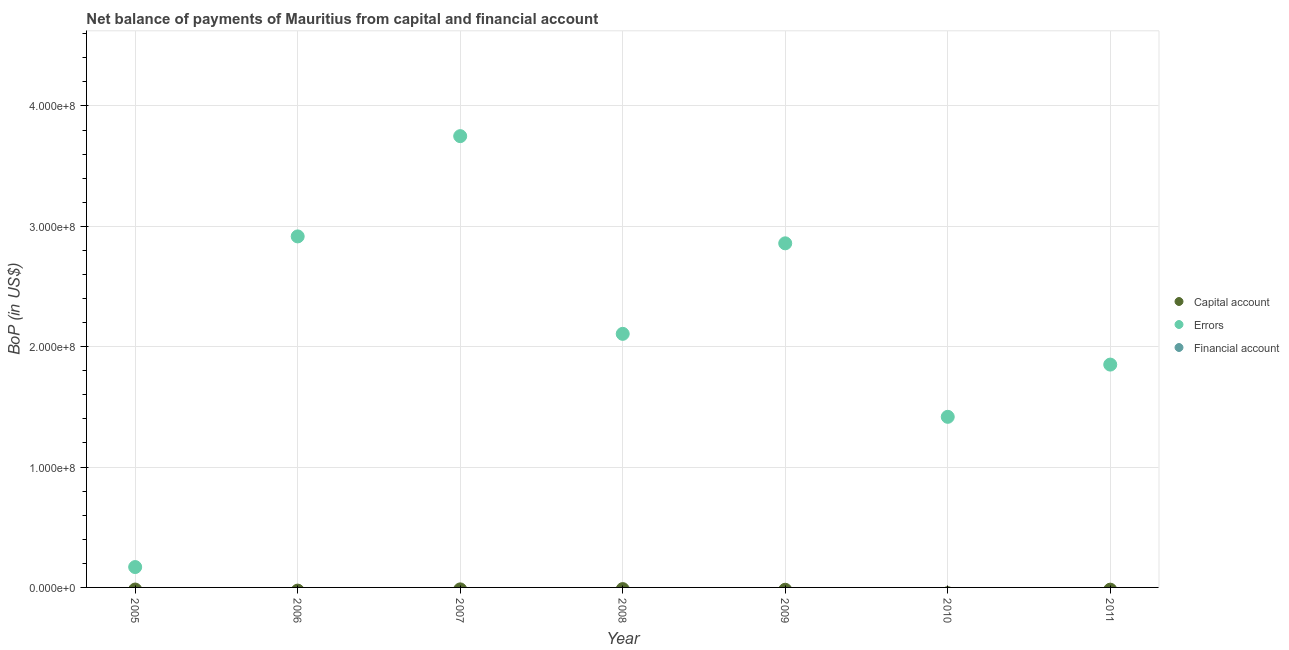What is the amount of errors in 2007?
Keep it short and to the point. 3.75e+08. Across all years, what is the maximum amount of errors?
Keep it short and to the point. 3.75e+08. In which year was the amount of errors maximum?
Your answer should be compact. 2007. What is the total amount of errors in the graph?
Offer a terse response. 1.51e+09. What is the difference between the amount of errors in 2007 and that in 2008?
Keep it short and to the point. 1.64e+08. What is the difference between the amount of errors in 2008 and the amount of net capital account in 2005?
Ensure brevity in your answer.  2.11e+08. What is the ratio of the amount of errors in 2005 to that in 2008?
Offer a terse response. 0.08. What is the difference between the highest and the second highest amount of errors?
Your response must be concise. 8.33e+07. What is the difference between the highest and the lowest amount of errors?
Offer a terse response. 3.58e+08. Is it the case that in every year, the sum of the amount of net capital account and amount of errors is greater than the amount of financial account?
Provide a short and direct response. Yes. Does the amount of errors monotonically increase over the years?
Your answer should be very brief. No. What is the difference between two consecutive major ticks on the Y-axis?
Keep it short and to the point. 1.00e+08. Are the values on the major ticks of Y-axis written in scientific E-notation?
Make the answer very short. Yes. Does the graph contain grids?
Provide a succinct answer. Yes. What is the title of the graph?
Your answer should be compact. Net balance of payments of Mauritius from capital and financial account. Does "Ages 60+" appear as one of the legend labels in the graph?
Your answer should be very brief. No. What is the label or title of the X-axis?
Your answer should be very brief. Year. What is the label or title of the Y-axis?
Provide a succinct answer. BoP (in US$). What is the BoP (in US$) in Errors in 2005?
Give a very brief answer. 1.69e+07. What is the BoP (in US$) in Capital account in 2006?
Your answer should be compact. 0. What is the BoP (in US$) in Errors in 2006?
Your answer should be compact. 2.92e+08. What is the BoP (in US$) of Financial account in 2006?
Give a very brief answer. 0. What is the BoP (in US$) in Errors in 2007?
Provide a short and direct response. 3.75e+08. What is the BoP (in US$) of Financial account in 2007?
Offer a very short reply. 0. What is the BoP (in US$) of Errors in 2008?
Provide a succinct answer. 2.11e+08. What is the BoP (in US$) of Capital account in 2009?
Ensure brevity in your answer.  0. What is the BoP (in US$) of Errors in 2009?
Give a very brief answer. 2.86e+08. What is the BoP (in US$) in Financial account in 2009?
Provide a succinct answer. 0. What is the BoP (in US$) in Errors in 2010?
Make the answer very short. 1.42e+08. What is the BoP (in US$) in Financial account in 2010?
Keep it short and to the point. 0. What is the BoP (in US$) of Capital account in 2011?
Keep it short and to the point. 0. What is the BoP (in US$) in Errors in 2011?
Make the answer very short. 1.85e+08. What is the BoP (in US$) in Financial account in 2011?
Give a very brief answer. 0. Across all years, what is the maximum BoP (in US$) in Errors?
Offer a terse response. 3.75e+08. Across all years, what is the minimum BoP (in US$) in Errors?
Provide a short and direct response. 1.69e+07. What is the total BoP (in US$) in Capital account in the graph?
Your answer should be very brief. 0. What is the total BoP (in US$) of Errors in the graph?
Give a very brief answer. 1.51e+09. What is the total BoP (in US$) in Financial account in the graph?
Provide a succinct answer. 0. What is the difference between the BoP (in US$) of Errors in 2005 and that in 2006?
Make the answer very short. -2.75e+08. What is the difference between the BoP (in US$) in Errors in 2005 and that in 2007?
Offer a terse response. -3.58e+08. What is the difference between the BoP (in US$) of Errors in 2005 and that in 2008?
Ensure brevity in your answer.  -1.94e+08. What is the difference between the BoP (in US$) in Errors in 2005 and that in 2009?
Your response must be concise. -2.69e+08. What is the difference between the BoP (in US$) of Errors in 2005 and that in 2010?
Provide a short and direct response. -1.25e+08. What is the difference between the BoP (in US$) of Errors in 2005 and that in 2011?
Keep it short and to the point. -1.68e+08. What is the difference between the BoP (in US$) in Errors in 2006 and that in 2007?
Your response must be concise. -8.33e+07. What is the difference between the BoP (in US$) of Errors in 2006 and that in 2008?
Give a very brief answer. 8.10e+07. What is the difference between the BoP (in US$) of Errors in 2006 and that in 2009?
Offer a very short reply. 5.75e+06. What is the difference between the BoP (in US$) of Errors in 2006 and that in 2010?
Your answer should be compact. 1.50e+08. What is the difference between the BoP (in US$) of Errors in 2006 and that in 2011?
Keep it short and to the point. 1.07e+08. What is the difference between the BoP (in US$) of Errors in 2007 and that in 2008?
Your response must be concise. 1.64e+08. What is the difference between the BoP (in US$) in Errors in 2007 and that in 2009?
Offer a terse response. 8.90e+07. What is the difference between the BoP (in US$) of Errors in 2007 and that in 2010?
Offer a very short reply. 2.33e+08. What is the difference between the BoP (in US$) of Errors in 2007 and that in 2011?
Provide a short and direct response. 1.90e+08. What is the difference between the BoP (in US$) of Errors in 2008 and that in 2009?
Ensure brevity in your answer.  -7.52e+07. What is the difference between the BoP (in US$) of Errors in 2008 and that in 2010?
Offer a very short reply. 6.89e+07. What is the difference between the BoP (in US$) of Errors in 2008 and that in 2011?
Offer a terse response. 2.55e+07. What is the difference between the BoP (in US$) in Errors in 2009 and that in 2010?
Offer a very short reply. 1.44e+08. What is the difference between the BoP (in US$) of Errors in 2009 and that in 2011?
Your answer should be very brief. 1.01e+08. What is the difference between the BoP (in US$) in Errors in 2010 and that in 2011?
Ensure brevity in your answer.  -4.34e+07. What is the average BoP (in US$) of Errors per year?
Provide a succinct answer. 2.15e+08. What is the ratio of the BoP (in US$) of Errors in 2005 to that in 2006?
Ensure brevity in your answer.  0.06. What is the ratio of the BoP (in US$) of Errors in 2005 to that in 2007?
Your answer should be very brief. 0.05. What is the ratio of the BoP (in US$) of Errors in 2005 to that in 2008?
Ensure brevity in your answer.  0.08. What is the ratio of the BoP (in US$) of Errors in 2005 to that in 2009?
Provide a succinct answer. 0.06. What is the ratio of the BoP (in US$) of Errors in 2005 to that in 2010?
Provide a succinct answer. 0.12. What is the ratio of the BoP (in US$) in Errors in 2005 to that in 2011?
Keep it short and to the point. 0.09. What is the ratio of the BoP (in US$) in Errors in 2006 to that in 2007?
Provide a short and direct response. 0.78. What is the ratio of the BoP (in US$) of Errors in 2006 to that in 2008?
Your answer should be very brief. 1.38. What is the ratio of the BoP (in US$) in Errors in 2006 to that in 2009?
Offer a very short reply. 1.02. What is the ratio of the BoP (in US$) in Errors in 2006 to that in 2010?
Your answer should be very brief. 2.06. What is the ratio of the BoP (in US$) in Errors in 2006 to that in 2011?
Provide a short and direct response. 1.58. What is the ratio of the BoP (in US$) in Errors in 2007 to that in 2008?
Provide a succinct answer. 1.78. What is the ratio of the BoP (in US$) in Errors in 2007 to that in 2009?
Your answer should be compact. 1.31. What is the ratio of the BoP (in US$) of Errors in 2007 to that in 2010?
Offer a terse response. 2.65. What is the ratio of the BoP (in US$) of Errors in 2007 to that in 2011?
Your answer should be compact. 2.03. What is the ratio of the BoP (in US$) in Errors in 2008 to that in 2009?
Provide a succinct answer. 0.74. What is the ratio of the BoP (in US$) of Errors in 2008 to that in 2010?
Offer a very short reply. 1.49. What is the ratio of the BoP (in US$) of Errors in 2008 to that in 2011?
Your response must be concise. 1.14. What is the ratio of the BoP (in US$) in Errors in 2009 to that in 2010?
Your response must be concise. 2.02. What is the ratio of the BoP (in US$) of Errors in 2009 to that in 2011?
Your response must be concise. 1.54. What is the ratio of the BoP (in US$) of Errors in 2010 to that in 2011?
Make the answer very short. 0.77. What is the difference between the highest and the second highest BoP (in US$) in Errors?
Provide a succinct answer. 8.33e+07. What is the difference between the highest and the lowest BoP (in US$) of Errors?
Your response must be concise. 3.58e+08. 